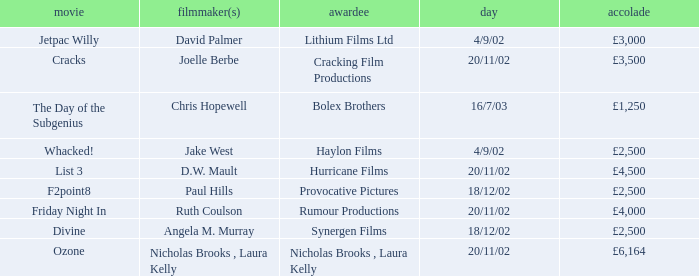Who won an award of £3,000 on 4/9/02? Lithium Films Ltd. 